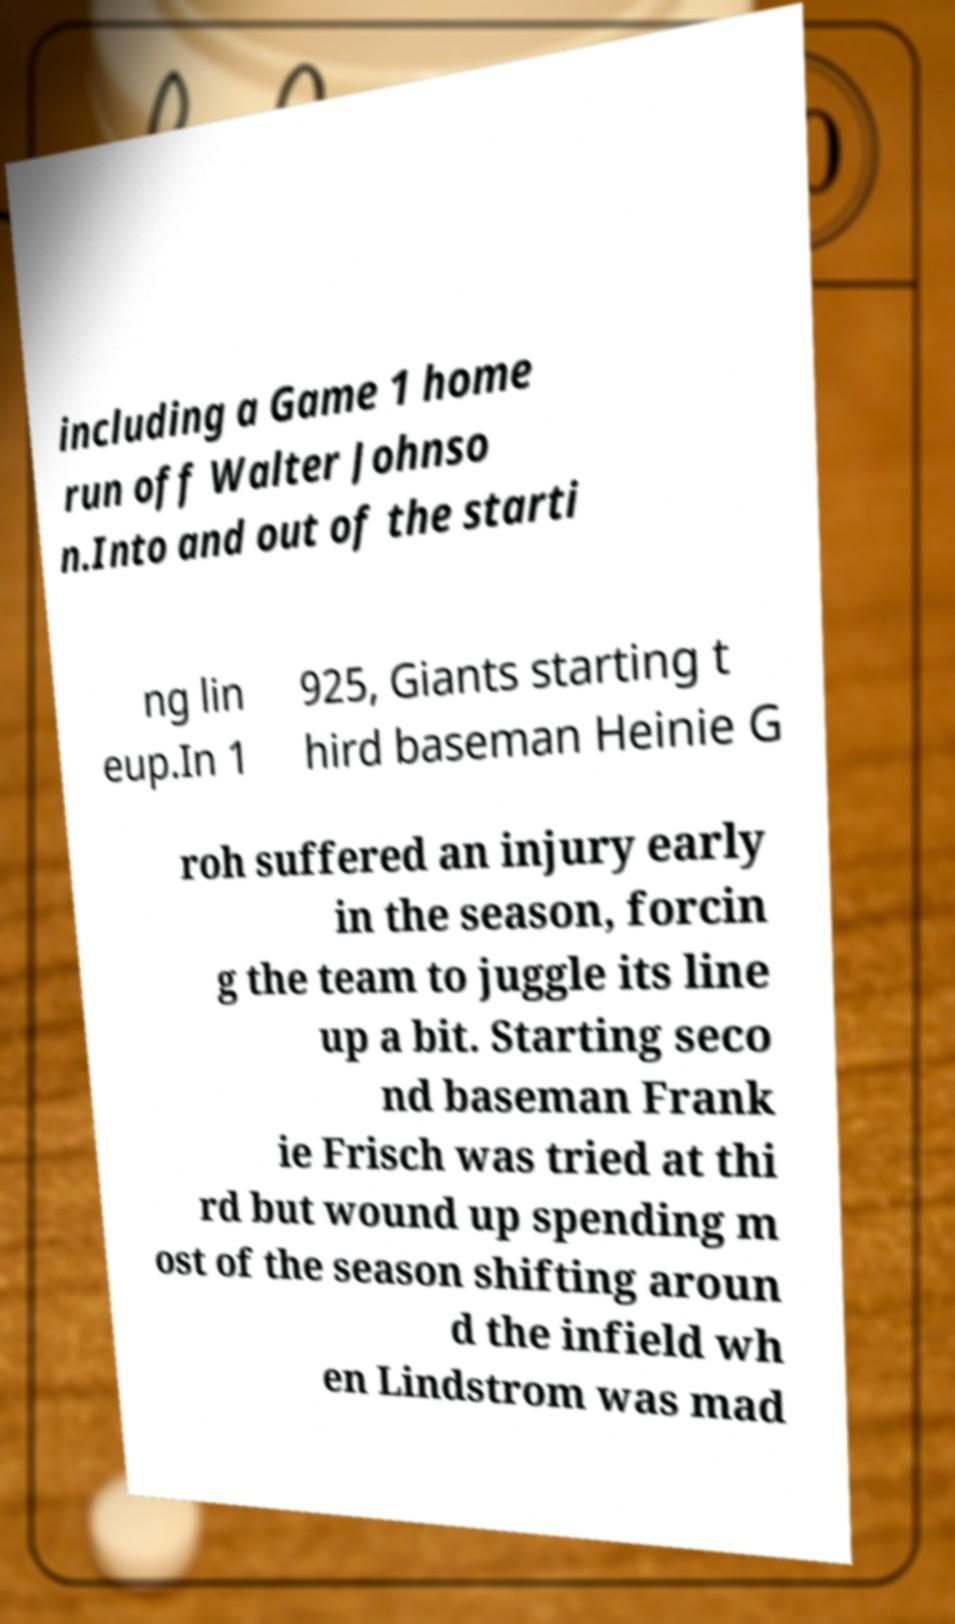Can you accurately transcribe the text from the provided image for me? including a Game 1 home run off Walter Johnso n.Into and out of the starti ng lin eup.In 1 925, Giants starting t hird baseman Heinie G roh suffered an injury early in the season, forcin g the team to juggle its line up a bit. Starting seco nd baseman Frank ie Frisch was tried at thi rd but wound up spending m ost of the season shifting aroun d the infield wh en Lindstrom was mad 